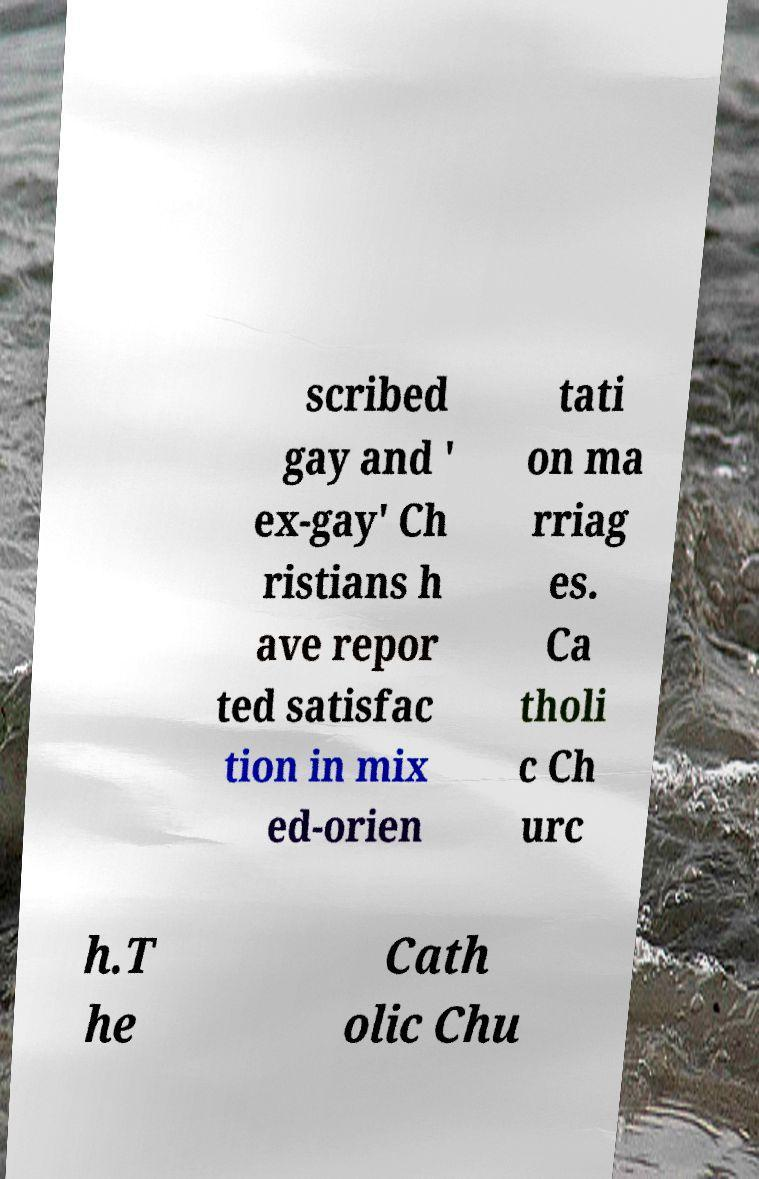Could you extract and type out the text from this image? scribed gay and ' ex-gay' Ch ristians h ave repor ted satisfac tion in mix ed-orien tati on ma rriag es. Ca tholi c Ch urc h.T he Cath olic Chu 